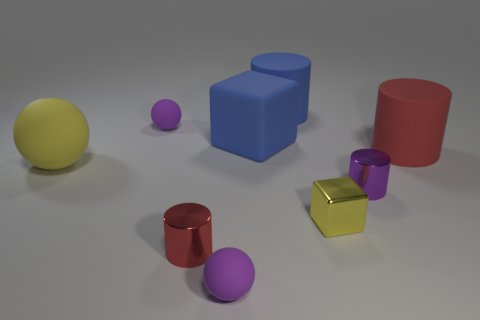Subtract 1 cylinders. How many cylinders are left? 3 Add 1 rubber cubes. How many objects exist? 10 Subtract all balls. How many objects are left? 6 Add 4 large blue rubber spheres. How many large blue rubber spheres exist? 4 Subtract 0 red cubes. How many objects are left? 9 Subtract all tiny rubber spheres. Subtract all small red things. How many objects are left? 6 Add 5 blue cubes. How many blue cubes are left? 6 